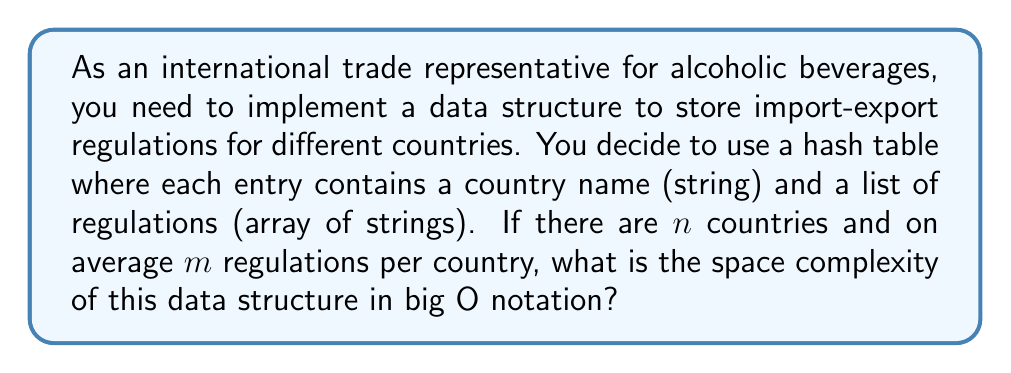Give your solution to this math problem. To analyze the space complexity of this data structure, we need to consider the following components:

1. Hash table:
   - The hash table itself requires $O(n)$ space to store $n$ entries (one for each country).

2. Country names:
   - Each country name is a string. Let's assume the average length of a country name is $k$.
   - The total space for country names is $O(n \cdot k)$.

3. Regulation lists:
   - For each country, we store a list of $m$ regulations on average.
   - Each regulation is a string. Let's assume the average length of a regulation is $r$.
   - The total space for regulations is $O(n \cdot m \cdot r)$.

Combining these components, the total space complexity is:

$$O(n + n \cdot k + n \cdot m \cdot r)$$

We can simplify this expression:

1. $O(n)$ is dominated by $O(n \cdot k)$ since $k \geq 1$ (country names have at least one character).
2. $O(n \cdot k)$ is dominated by $O(n \cdot m \cdot r)$ since typically $m \cdot r > k$ (the total length of regulations is likely greater than the country name length).

Therefore, we can express the space complexity as:

$$O(n \cdot m \cdot r)$$

This represents the space required to store $n$ countries, each with $m$ regulations of average length $r$.
Answer: $O(n \cdot m \cdot r)$, where $n$ is the number of countries, $m$ is the average number of regulations per country, and $r$ is the average length of a regulation. 